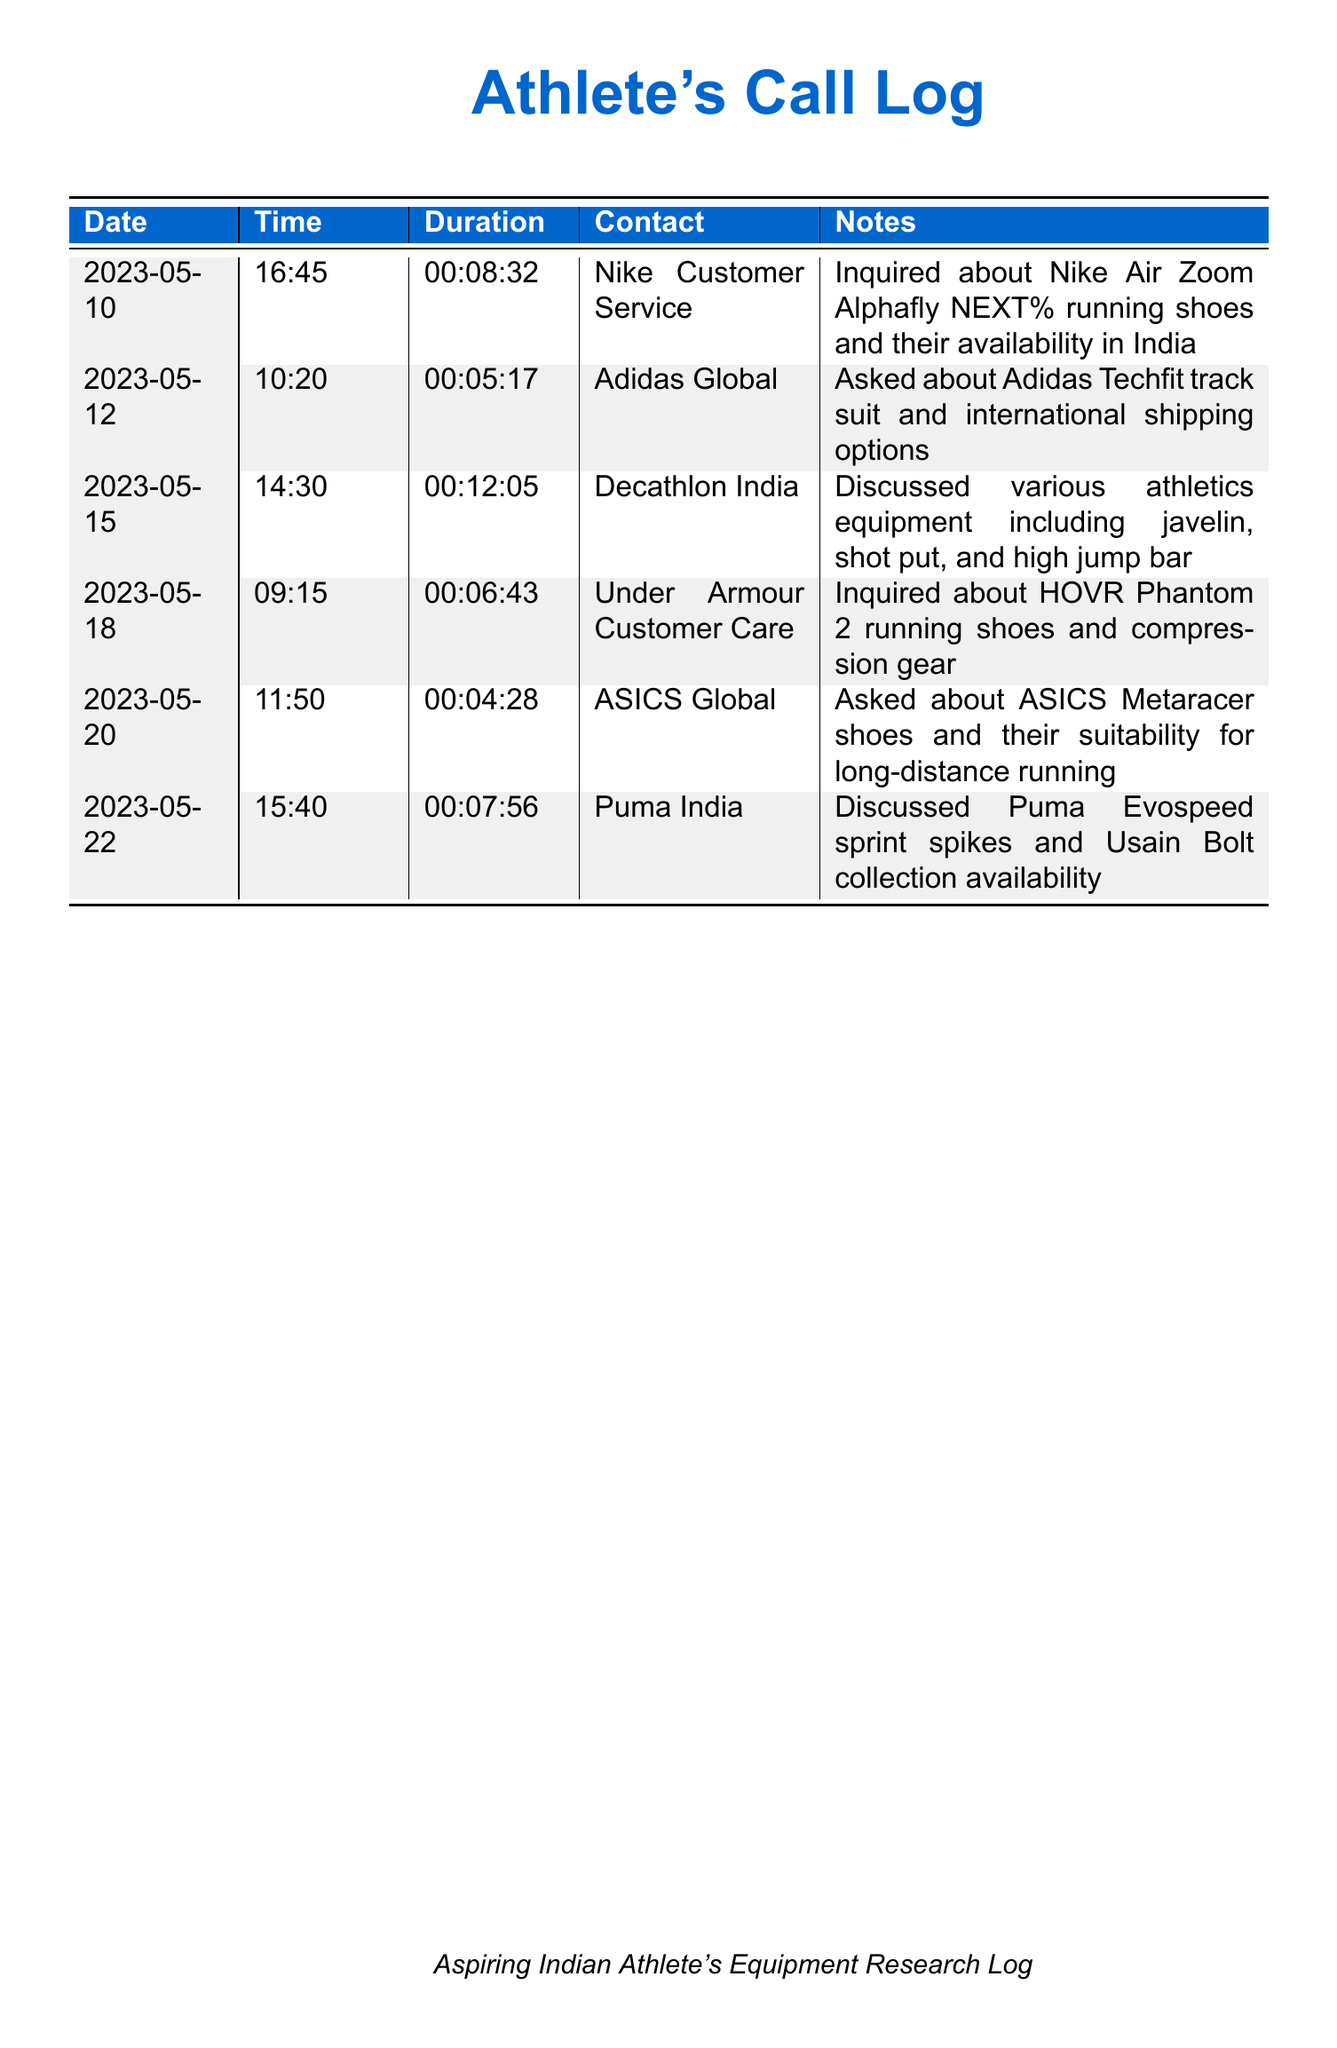What date did I contact Nike Customer Service? The date of the call to Nike Customer Service is specified in the document as 2023-05-10.
Answer: 2023-05-10 What was the duration of the call to Adidas Global? The duration of the call to Adidas Global is provided in the document as 00:05:17.
Answer: 00:05:17 Which sports equipment supplier was contacted on May 15? The supplier contacted on May 15 is mentioned in the document as Decathlon India.
Answer: Decathlon India What running shoes did I inquire about with Under Armour? The running shoes I inquired about with Under Armour are specified in the document as HOVR Phantom 2.
Answer: HOVR Phantom 2 How many calls were made to sports equipment suppliers in total? The total number of calls made is the count of entries in the document, which is five.
Answer: Five Which brand has a collection associated with Usain Bolt? The brand that has a collection associated with Usain Bolt is mentioned in the document as Puma.
Answer: Puma What type of track suit did I inquire about from Adidas? The type of track suit I inquired about is stated in the document as Techfit.
Answer: Techfit Which footwear brand was asked about for long-distance running? The brand asked about for long-distance running is ASICS, as indicated in the document.
Answer: ASICS What key piece of athletics equipment was discussed during the call to Decathlon India? A key piece of athletics equipment discussed was javelin, as listed in the document.
Answer: Javelin 